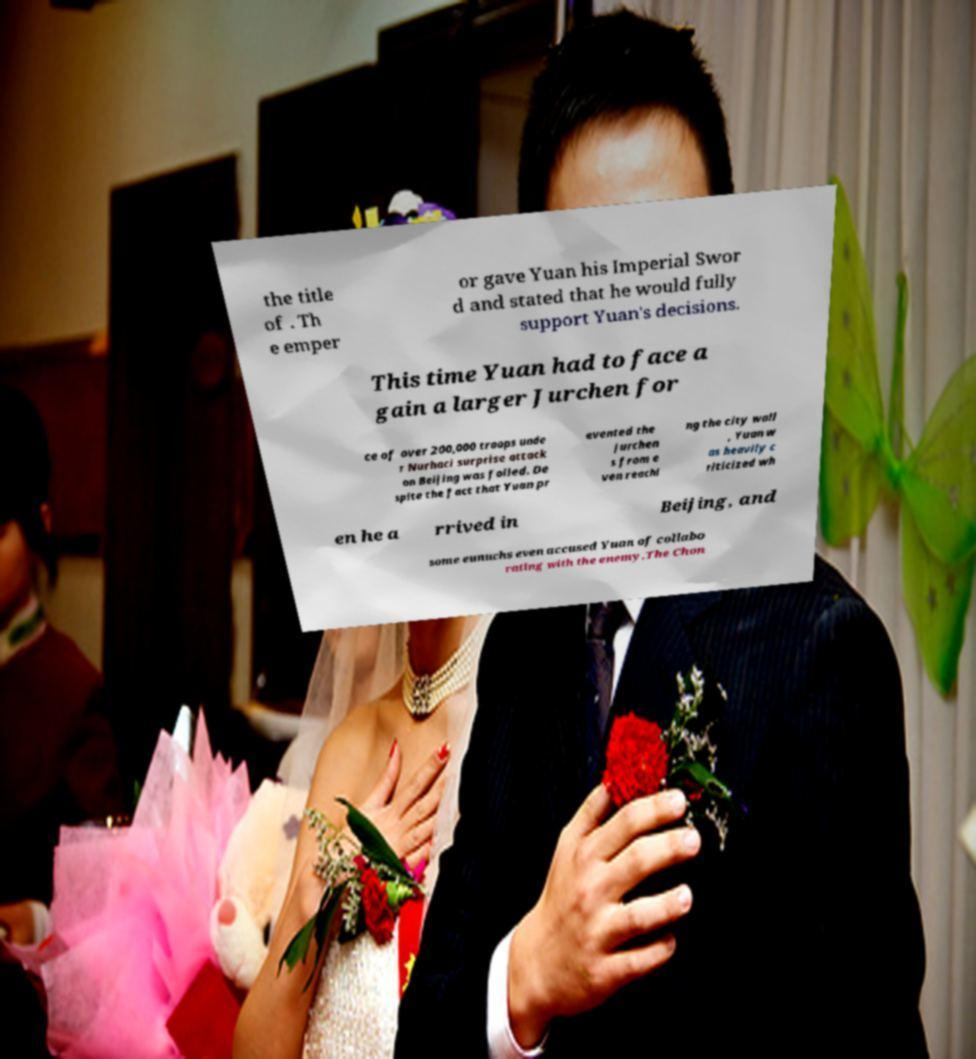For documentation purposes, I need the text within this image transcribed. Could you provide that? the title of . Th e emper or gave Yuan his Imperial Swor d and stated that he would fully support Yuan's decisions. This time Yuan had to face a gain a larger Jurchen for ce of over 200,000 troops unde r Nurhaci surprise attack on Beijing was foiled. De spite the fact that Yuan pr evented the Jurchen s from e ven reachi ng the city wall , Yuan w as heavily c riticized wh en he a rrived in Beijing, and some eunuchs even accused Yuan of collabo rating with the enemy.The Chon 